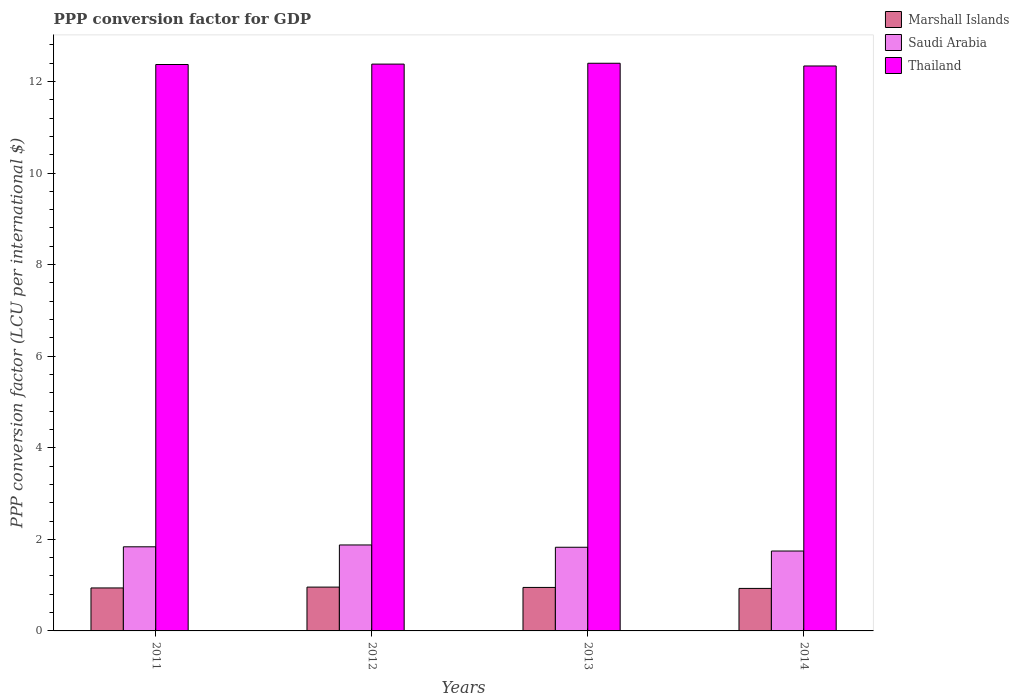How many different coloured bars are there?
Keep it short and to the point. 3. How many groups of bars are there?
Provide a succinct answer. 4. Are the number of bars per tick equal to the number of legend labels?
Provide a succinct answer. Yes. What is the label of the 3rd group of bars from the left?
Your answer should be compact. 2013. In how many cases, is the number of bars for a given year not equal to the number of legend labels?
Ensure brevity in your answer.  0. What is the PPP conversion factor for GDP in Thailand in 2012?
Ensure brevity in your answer.  12.38. Across all years, what is the maximum PPP conversion factor for GDP in Marshall Islands?
Your answer should be very brief. 0.96. Across all years, what is the minimum PPP conversion factor for GDP in Saudi Arabia?
Give a very brief answer. 1.74. In which year was the PPP conversion factor for GDP in Thailand minimum?
Make the answer very short. 2014. What is the total PPP conversion factor for GDP in Marshall Islands in the graph?
Provide a succinct answer. 3.77. What is the difference between the PPP conversion factor for GDP in Thailand in 2012 and that in 2013?
Offer a very short reply. -0.02. What is the difference between the PPP conversion factor for GDP in Marshall Islands in 2012 and the PPP conversion factor for GDP in Saudi Arabia in 2013?
Provide a short and direct response. -0.87. What is the average PPP conversion factor for GDP in Saudi Arabia per year?
Offer a terse response. 1.82. In the year 2013, what is the difference between the PPP conversion factor for GDP in Thailand and PPP conversion factor for GDP in Saudi Arabia?
Offer a terse response. 10.57. What is the ratio of the PPP conversion factor for GDP in Marshall Islands in 2011 to that in 2014?
Your answer should be very brief. 1.01. Is the PPP conversion factor for GDP in Saudi Arabia in 2011 less than that in 2013?
Your answer should be compact. No. What is the difference between the highest and the second highest PPP conversion factor for GDP in Saudi Arabia?
Your answer should be very brief. 0.04. What is the difference between the highest and the lowest PPP conversion factor for GDP in Marshall Islands?
Offer a terse response. 0.03. In how many years, is the PPP conversion factor for GDP in Saudi Arabia greater than the average PPP conversion factor for GDP in Saudi Arabia taken over all years?
Provide a short and direct response. 3. What does the 3rd bar from the left in 2012 represents?
Offer a very short reply. Thailand. What does the 2nd bar from the right in 2012 represents?
Provide a short and direct response. Saudi Arabia. Is it the case that in every year, the sum of the PPP conversion factor for GDP in Marshall Islands and PPP conversion factor for GDP in Thailand is greater than the PPP conversion factor for GDP in Saudi Arabia?
Ensure brevity in your answer.  Yes. How many bars are there?
Your response must be concise. 12. How many years are there in the graph?
Provide a succinct answer. 4. What is the difference between two consecutive major ticks on the Y-axis?
Offer a very short reply. 2. How are the legend labels stacked?
Offer a very short reply. Vertical. What is the title of the graph?
Offer a terse response. PPP conversion factor for GDP. What is the label or title of the X-axis?
Your answer should be very brief. Years. What is the label or title of the Y-axis?
Keep it short and to the point. PPP conversion factor (LCU per international $). What is the PPP conversion factor (LCU per international $) of Marshall Islands in 2011?
Ensure brevity in your answer.  0.94. What is the PPP conversion factor (LCU per international $) of Saudi Arabia in 2011?
Provide a short and direct response. 1.84. What is the PPP conversion factor (LCU per international $) in Thailand in 2011?
Your response must be concise. 12.37. What is the PPP conversion factor (LCU per international $) in Marshall Islands in 2012?
Keep it short and to the point. 0.96. What is the PPP conversion factor (LCU per international $) in Saudi Arabia in 2012?
Offer a very short reply. 1.88. What is the PPP conversion factor (LCU per international $) of Thailand in 2012?
Ensure brevity in your answer.  12.38. What is the PPP conversion factor (LCU per international $) in Marshall Islands in 2013?
Provide a succinct answer. 0.95. What is the PPP conversion factor (LCU per international $) of Saudi Arabia in 2013?
Your answer should be compact. 1.83. What is the PPP conversion factor (LCU per international $) of Thailand in 2013?
Your answer should be compact. 12.4. What is the PPP conversion factor (LCU per international $) in Marshall Islands in 2014?
Ensure brevity in your answer.  0.93. What is the PPP conversion factor (LCU per international $) in Saudi Arabia in 2014?
Ensure brevity in your answer.  1.74. What is the PPP conversion factor (LCU per international $) in Thailand in 2014?
Offer a terse response. 12.34. Across all years, what is the maximum PPP conversion factor (LCU per international $) in Marshall Islands?
Your response must be concise. 0.96. Across all years, what is the maximum PPP conversion factor (LCU per international $) in Saudi Arabia?
Provide a succinct answer. 1.88. Across all years, what is the maximum PPP conversion factor (LCU per international $) in Thailand?
Provide a short and direct response. 12.4. Across all years, what is the minimum PPP conversion factor (LCU per international $) of Marshall Islands?
Ensure brevity in your answer.  0.93. Across all years, what is the minimum PPP conversion factor (LCU per international $) in Saudi Arabia?
Your answer should be compact. 1.74. Across all years, what is the minimum PPP conversion factor (LCU per international $) of Thailand?
Keep it short and to the point. 12.34. What is the total PPP conversion factor (LCU per international $) of Marshall Islands in the graph?
Provide a succinct answer. 3.77. What is the total PPP conversion factor (LCU per international $) of Saudi Arabia in the graph?
Give a very brief answer. 7.29. What is the total PPP conversion factor (LCU per international $) of Thailand in the graph?
Your answer should be very brief. 49.49. What is the difference between the PPP conversion factor (LCU per international $) of Marshall Islands in 2011 and that in 2012?
Give a very brief answer. -0.02. What is the difference between the PPP conversion factor (LCU per international $) of Saudi Arabia in 2011 and that in 2012?
Provide a short and direct response. -0.04. What is the difference between the PPP conversion factor (LCU per international $) in Thailand in 2011 and that in 2012?
Offer a very short reply. -0.01. What is the difference between the PPP conversion factor (LCU per international $) in Marshall Islands in 2011 and that in 2013?
Provide a short and direct response. -0.01. What is the difference between the PPP conversion factor (LCU per international $) in Saudi Arabia in 2011 and that in 2013?
Give a very brief answer. 0.01. What is the difference between the PPP conversion factor (LCU per international $) in Thailand in 2011 and that in 2013?
Provide a succinct answer. -0.03. What is the difference between the PPP conversion factor (LCU per international $) of Marshall Islands in 2011 and that in 2014?
Provide a short and direct response. 0.01. What is the difference between the PPP conversion factor (LCU per international $) in Saudi Arabia in 2011 and that in 2014?
Keep it short and to the point. 0.09. What is the difference between the PPP conversion factor (LCU per international $) in Thailand in 2011 and that in 2014?
Your response must be concise. 0.03. What is the difference between the PPP conversion factor (LCU per international $) in Marshall Islands in 2012 and that in 2013?
Your answer should be very brief. 0.01. What is the difference between the PPP conversion factor (LCU per international $) in Saudi Arabia in 2012 and that in 2013?
Provide a short and direct response. 0.05. What is the difference between the PPP conversion factor (LCU per international $) of Thailand in 2012 and that in 2013?
Provide a short and direct response. -0.02. What is the difference between the PPP conversion factor (LCU per international $) of Marshall Islands in 2012 and that in 2014?
Provide a short and direct response. 0.03. What is the difference between the PPP conversion factor (LCU per international $) of Saudi Arabia in 2012 and that in 2014?
Give a very brief answer. 0.13. What is the difference between the PPP conversion factor (LCU per international $) of Thailand in 2012 and that in 2014?
Your answer should be very brief. 0.04. What is the difference between the PPP conversion factor (LCU per international $) of Marshall Islands in 2013 and that in 2014?
Provide a short and direct response. 0.02. What is the difference between the PPP conversion factor (LCU per international $) of Saudi Arabia in 2013 and that in 2014?
Provide a succinct answer. 0.08. What is the difference between the PPP conversion factor (LCU per international $) in Thailand in 2013 and that in 2014?
Provide a short and direct response. 0.06. What is the difference between the PPP conversion factor (LCU per international $) of Marshall Islands in 2011 and the PPP conversion factor (LCU per international $) of Saudi Arabia in 2012?
Offer a very short reply. -0.94. What is the difference between the PPP conversion factor (LCU per international $) of Marshall Islands in 2011 and the PPP conversion factor (LCU per international $) of Thailand in 2012?
Provide a succinct answer. -11.44. What is the difference between the PPP conversion factor (LCU per international $) of Saudi Arabia in 2011 and the PPP conversion factor (LCU per international $) of Thailand in 2012?
Your answer should be very brief. -10.54. What is the difference between the PPP conversion factor (LCU per international $) in Marshall Islands in 2011 and the PPP conversion factor (LCU per international $) in Saudi Arabia in 2013?
Offer a terse response. -0.89. What is the difference between the PPP conversion factor (LCU per international $) in Marshall Islands in 2011 and the PPP conversion factor (LCU per international $) in Thailand in 2013?
Ensure brevity in your answer.  -11.46. What is the difference between the PPP conversion factor (LCU per international $) in Saudi Arabia in 2011 and the PPP conversion factor (LCU per international $) in Thailand in 2013?
Your response must be concise. -10.56. What is the difference between the PPP conversion factor (LCU per international $) of Marshall Islands in 2011 and the PPP conversion factor (LCU per international $) of Saudi Arabia in 2014?
Offer a terse response. -0.81. What is the difference between the PPP conversion factor (LCU per international $) of Marshall Islands in 2011 and the PPP conversion factor (LCU per international $) of Thailand in 2014?
Offer a very short reply. -11.4. What is the difference between the PPP conversion factor (LCU per international $) in Saudi Arabia in 2011 and the PPP conversion factor (LCU per international $) in Thailand in 2014?
Provide a succinct answer. -10.5. What is the difference between the PPP conversion factor (LCU per international $) in Marshall Islands in 2012 and the PPP conversion factor (LCU per international $) in Saudi Arabia in 2013?
Your answer should be very brief. -0.87. What is the difference between the PPP conversion factor (LCU per international $) of Marshall Islands in 2012 and the PPP conversion factor (LCU per international $) of Thailand in 2013?
Give a very brief answer. -11.44. What is the difference between the PPP conversion factor (LCU per international $) of Saudi Arabia in 2012 and the PPP conversion factor (LCU per international $) of Thailand in 2013?
Give a very brief answer. -10.52. What is the difference between the PPP conversion factor (LCU per international $) in Marshall Islands in 2012 and the PPP conversion factor (LCU per international $) in Saudi Arabia in 2014?
Ensure brevity in your answer.  -0.79. What is the difference between the PPP conversion factor (LCU per international $) in Marshall Islands in 2012 and the PPP conversion factor (LCU per international $) in Thailand in 2014?
Make the answer very short. -11.38. What is the difference between the PPP conversion factor (LCU per international $) in Saudi Arabia in 2012 and the PPP conversion factor (LCU per international $) in Thailand in 2014?
Provide a short and direct response. -10.46. What is the difference between the PPP conversion factor (LCU per international $) in Marshall Islands in 2013 and the PPP conversion factor (LCU per international $) in Saudi Arabia in 2014?
Offer a terse response. -0.8. What is the difference between the PPP conversion factor (LCU per international $) in Marshall Islands in 2013 and the PPP conversion factor (LCU per international $) in Thailand in 2014?
Ensure brevity in your answer.  -11.39. What is the difference between the PPP conversion factor (LCU per international $) in Saudi Arabia in 2013 and the PPP conversion factor (LCU per international $) in Thailand in 2014?
Make the answer very short. -10.51. What is the average PPP conversion factor (LCU per international $) of Marshall Islands per year?
Your answer should be very brief. 0.94. What is the average PPP conversion factor (LCU per international $) of Saudi Arabia per year?
Offer a terse response. 1.82. What is the average PPP conversion factor (LCU per international $) of Thailand per year?
Provide a short and direct response. 12.37. In the year 2011, what is the difference between the PPP conversion factor (LCU per international $) of Marshall Islands and PPP conversion factor (LCU per international $) of Saudi Arabia?
Keep it short and to the point. -0.9. In the year 2011, what is the difference between the PPP conversion factor (LCU per international $) of Marshall Islands and PPP conversion factor (LCU per international $) of Thailand?
Keep it short and to the point. -11.43. In the year 2011, what is the difference between the PPP conversion factor (LCU per international $) in Saudi Arabia and PPP conversion factor (LCU per international $) in Thailand?
Make the answer very short. -10.53. In the year 2012, what is the difference between the PPP conversion factor (LCU per international $) in Marshall Islands and PPP conversion factor (LCU per international $) in Saudi Arabia?
Give a very brief answer. -0.92. In the year 2012, what is the difference between the PPP conversion factor (LCU per international $) of Marshall Islands and PPP conversion factor (LCU per international $) of Thailand?
Make the answer very short. -11.42. In the year 2012, what is the difference between the PPP conversion factor (LCU per international $) of Saudi Arabia and PPP conversion factor (LCU per international $) of Thailand?
Offer a terse response. -10.5. In the year 2013, what is the difference between the PPP conversion factor (LCU per international $) of Marshall Islands and PPP conversion factor (LCU per international $) of Saudi Arabia?
Provide a short and direct response. -0.88. In the year 2013, what is the difference between the PPP conversion factor (LCU per international $) of Marshall Islands and PPP conversion factor (LCU per international $) of Thailand?
Make the answer very short. -11.45. In the year 2013, what is the difference between the PPP conversion factor (LCU per international $) of Saudi Arabia and PPP conversion factor (LCU per international $) of Thailand?
Provide a short and direct response. -10.57. In the year 2014, what is the difference between the PPP conversion factor (LCU per international $) of Marshall Islands and PPP conversion factor (LCU per international $) of Saudi Arabia?
Give a very brief answer. -0.82. In the year 2014, what is the difference between the PPP conversion factor (LCU per international $) in Marshall Islands and PPP conversion factor (LCU per international $) in Thailand?
Ensure brevity in your answer.  -11.41. In the year 2014, what is the difference between the PPP conversion factor (LCU per international $) of Saudi Arabia and PPP conversion factor (LCU per international $) of Thailand?
Offer a very short reply. -10.59. What is the ratio of the PPP conversion factor (LCU per international $) in Marshall Islands in 2011 to that in 2012?
Offer a terse response. 0.98. What is the ratio of the PPP conversion factor (LCU per international $) in Saudi Arabia in 2011 to that in 2012?
Offer a very short reply. 0.98. What is the ratio of the PPP conversion factor (LCU per international $) in Thailand in 2011 to that in 2012?
Your answer should be very brief. 1. What is the ratio of the PPP conversion factor (LCU per international $) of Marshall Islands in 2011 to that in 2013?
Keep it short and to the point. 0.99. What is the ratio of the PPP conversion factor (LCU per international $) in Saudi Arabia in 2011 to that in 2013?
Make the answer very short. 1.01. What is the ratio of the PPP conversion factor (LCU per international $) in Marshall Islands in 2011 to that in 2014?
Keep it short and to the point. 1.01. What is the ratio of the PPP conversion factor (LCU per international $) of Saudi Arabia in 2011 to that in 2014?
Your response must be concise. 1.05. What is the ratio of the PPP conversion factor (LCU per international $) of Marshall Islands in 2012 to that in 2013?
Ensure brevity in your answer.  1.01. What is the ratio of the PPP conversion factor (LCU per international $) of Saudi Arabia in 2012 to that in 2013?
Provide a succinct answer. 1.03. What is the ratio of the PPP conversion factor (LCU per international $) of Thailand in 2012 to that in 2013?
Ensure brevity in your answer.  1. What is the ratio of the PPP conversion factor (LCU per international $) in Marshall Islands in 2012 to that in 2014?
Your answer should be very brief. 1.03. What is the ratio of the PPP conversion factor (LCU per international $) of Saudi Arabia in 2012 to that in 2014?
Your answer should be compact. 1.08. What is the ratio of the PPP conversion factor (LCU per international $) of Marshall Islands in 2013 to that in 2014?
Provide a succinct answer. 1.02. What is the ratio of the PPP conversion factor (LCU per international $) in Saudi Arabia in 2013 to that in 2014?
Make the answer very short. 1.05. What is the ratio of the PPP conversion factor (LCU per international $) of Thailand in 2013 to that in 2014?
Offer a very short reply. 1. What is the difference between the highest and the second highest PPP conversion factor (LCU per international $) in Marshall Islands?
Keep it short and to the point. 0.01. What is the difference between the highest and the second highest PPP conversion factor (LCU per international $) in Saudi Arabia?
Keep it short and to the point. 0.04. What is the difference between the highest and the second highest PPP conversion factor (LCU per international $) in Thailand?
Your answer should be very brief. 0.02. What is the difference between the highest and the lowest PPP conversion factor (LCU per international $) of Marshall Islands?
Ensure brevity in your answer.  0.03. What is the difference between the highest and the lowest PPP conversion factor (LCU per international $) in Saudi Arabia?
Offer a very short reply. 0.13. What is the difference between the highest and the lowest PPP conversion factor (LCU per international $) in Thailand?
Offer a terse response. 0.06. 